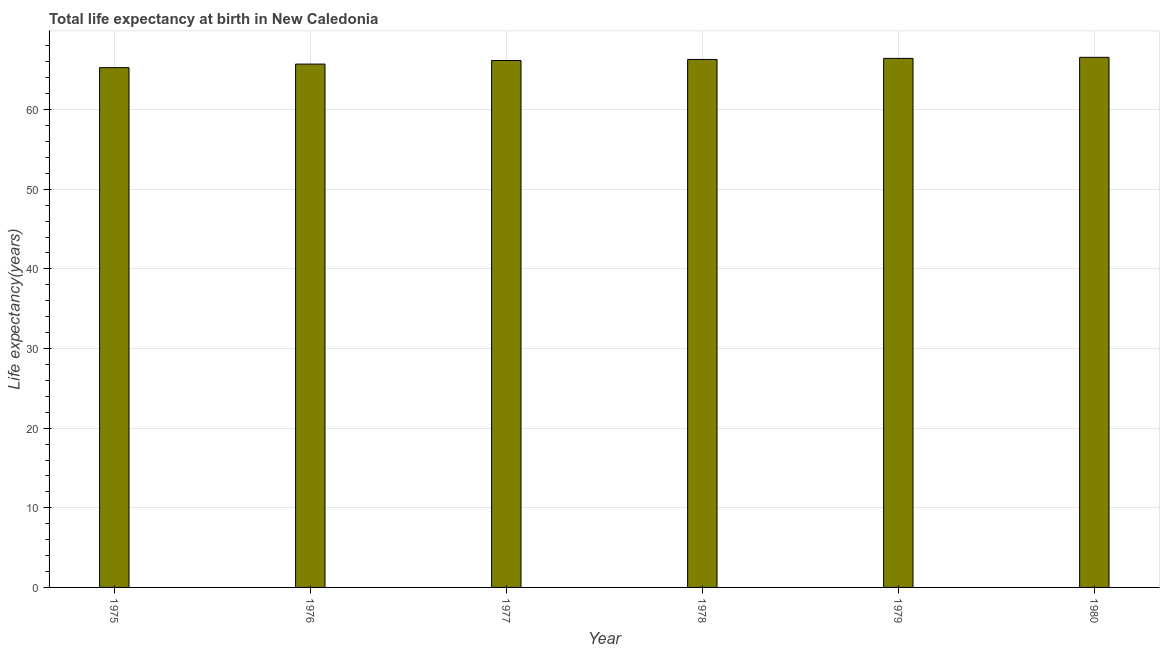What is the title of the graph?
Your response must be concise. Total life expectancy at birth in New Caledonia. What is the label or title of the X-axis?
Provide a short and direct response. Year. What is the label or title of the Y-axis?
Make the answer very short. Life expectancy(years). What is the life expectancy at birth in 1979?
Ensure brevity in your answer.  66.44. Across all years, what is the maximum life expectancy at birth?
Offer a very short reply. 66.57. Across all years, what is the minimum life expectancy at birth?
Your answer should be very brief. 65.27. In which year was the life expectancy at birth minimum?
Keep it short and to the point. 1975. What is the sum of the life expectancy at birth?
Offer a terse response. 396.48. What is the difference between the life expectancy at birth in 1977 and 1979?
Keep it short and to the point. -0.27. What is the average life expectancy at birth per year?
Provide a short and direct response. 66.08. What is the median life expectancy at birth?
Your answer should be very brief. 66.24. In how many years, is the life expectancy at birth greater than 40 years?
Offer a very short reply. 6. Is the life expectancy at birth in 1976 less than that in 1977?
Offer a very short reply. Yes. Is the difference between the life expectancy at birth in 1976 and 1978 greater than the difference between any two years?
Your answer should be very brief. No. What is the difference between the highest and the second highest life expectancy at birth?
Keep it short and to the point. 0.13. What is the difference between the highest and the lowest life expectancy at birth?
Offer a terse response. 1.3. In how many years, is the life expectancy at birth greater than the average life expectancy at birth taken over all years?
Provide a succinct answer. 4. How many bars are there?
Provide a short and direct response. 6. Are all the bars in the graph horizontal?
Provide a succinct answer. No. How many years are there in the graph?
Keep it short and to the point. 6. What is the difference between two consecutive major ticks on the Y-axis?
Ensure brevity in your answer.  10. What is the Life expectancy(years) of 1975?
Make the answer very short. 65.27. What is the Life expectancy(years) of 1976?
Provide a succinct answer. 65.72. What is the Life expectancy(years) of 1977?
Make the answer very short. 66.17. What is the Life expectancy(years) of 1978?
Keep it short and to the point. 66.3. What is the Life expectancy(years) of 1979?
Offer a very short reply. 66.44. What is the Life expectancy(years) in 1980?
Your answer should be compact. 66.57. What is the difference between the Life expectancy(years) in 1975 and 1976?
Ensure brevity in your answer.  -0.45. What is the difference between the Life expectancy(years) in 1975 and 1977?
Your answer should be very brief. -0.9. What is the difference between the Life expectancy(years) in 1975 and 1978?
Make the answer very short. -1.03. What is the difference between the Life expectancy(years) in 1975 and 1979?
Offer a very short reply. -1.16. What is the difference between the Life expectancy(years) in 1975 and 1980?
Make the answer very short. -1.3. What is the difference between the Life expectancy(years) in 1976 and 1977?
Offer a terse response. -0.45. What is the difference between the Life expectancy(years) in 1976 and 1978?
Provide a succinct answer. -0.58. What is the difference between the Life expectancy(years) in 1976 and 1979?
Ensure brevity in your answer.  -0.71. What is the difference between the Life expectancy(years) in 1976 and 1980?
Ensure brevity in your answer.  -0.85. What is the difference between the Life expectancy(years) in 1977 and 1978?
Provide a short and direct response. -0.13. What is the difference between the Life expectancy(years) in 1977 and 1979?
Provide a short and direct response. -0.27. What is the difference between the Life expectancy(years) in 1977 and 1980?
Provide a short and direct response. -0.4. What is the difference between the Life expectancy(years) in 1978 and 1979?
Your answer should be very brief. -0.13. What is the difference between the Life expectancy(years) in 1978 and 1980?
Your response must be concise. -0.27. What is the difference between the Life expectancy(years) in 1979 and 1980?
Offer a terse response. -0.13. What is the ratio of the Life expectancy(years) in 1975 to that in 1976?
Give a very brief answer. 0.99. What is the ratio of the Life expectancy(years) in 1975 to that in 1977?
Offer a terse response. 0.99. What is the ratio of the Life expectancy(years) in 1975 to that in 1979?
Keep it short and to the point. 0.98. What is the ratio of the Life expectancy(years) in 1976 to that in 1977?
Offer a very short reply. 0.99. What is the ratio of the Life expectancy(years) in 1976 to that in 1979?
Give a very brief answer. 0.99. What is the ratio of the Life expectancy(years) in 1976 to that in 1980?
Provide a succinct answer. 0.99. What is the ratio of the Life expectancy(years) in 1977 to that in 1979?
Your response must be concise. 1. 